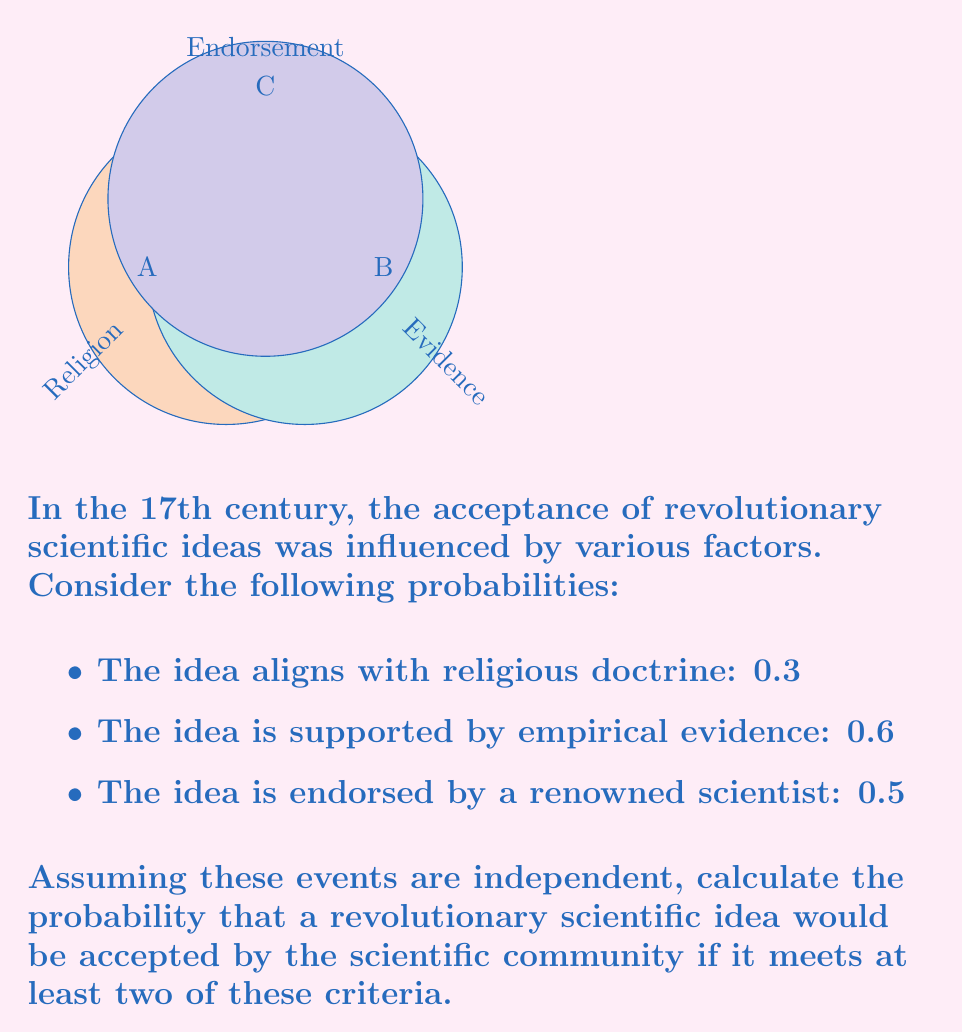Show me your answer to this math problem. To solve this problem, we'll use the concept of probability for independent events and the inclusion-exclusion principle.

Let's define our events:
A: The idea aligns with religious doctrine (P(A) = 0.3)
B: The idea is supported by empirical evidence (P(B) = 0.6)
C: The idea is endorsed by a renowned scientist (P(C) = 0.5)

We need to calculate the probability of at least two of these events occurring.

Step 1: Calculate the probability of exactly two events occurring:
P(AB not C) + P(AC not B) + P(BC not A)
$$ P(A)P(B)(1-P(C)) + P(A)P(C)(1-P(B)) + P(B)P(C)(1-P(A)) $$
$$ = 0.3 \cdot 0.6 \cdot 0.5 + 0.3 \cdot 0.5 \cdot 0.4 + 0.6 \cdot 0.5 \cdot 0.7 $$
$$ = 0.09 + 0.06 + 0.21 = 0.36 $$

Step 2: Calculate the probability of all three events occurring:
P(ABC)
$$ P(A)P(B)P(C) = 0.3 \cdot 0.6 \cdot 0.5 = 0.09 $$

Step 3: Sum the probabilities of exactly two and all three events occurring:
$$ P(\text{at least two}) = P(\text{exactly two}) + P(\text{all three}) $$
$$ = 0.36 + 0.09 = 0.45 $$

Therefore, the probability that a revolutionary scientific idea would be accepted by the scientific community if it meets at least two of these criteria is 0.45 or 45%.
Answer: 0.45 